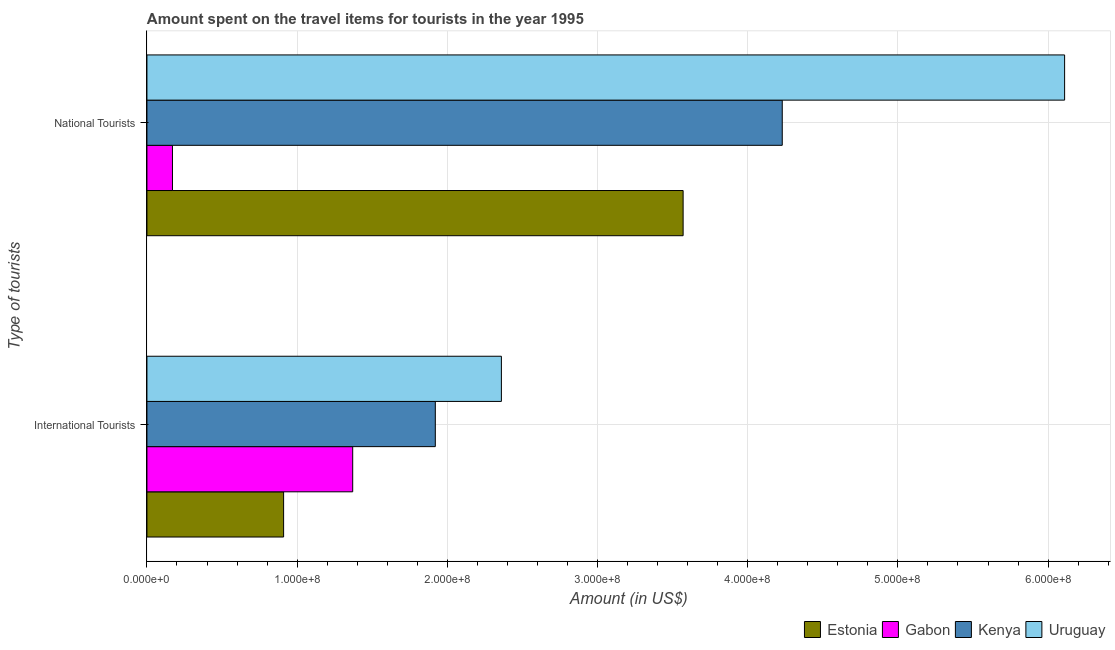How many groups of bars are there?
Your response must be concise. 2. Are the number of bars per tick equal to the number of legend labels?
Make the answer very short. Yes. How many bars are there on the 1st tick from the top?
Your response must be concise. 4. How many bars are there on the 2nd tick from the bottom?
Give a very brief answer. 4. What is the label of the 2nd group of bars from the top?
Offer a very short reply. International Tourists. What is the amount spent on travel items of national tourists in Uruguay?
Provide a succinct answer. 6.11e+08. Across all countries, what is the maximum amount spent on travel items of international tourists?
Your response must be concise. 2.36e+08. Across all countries, what is the minimum amount spent on travel items of national tourists?
Your answer should be very brief. 1.70e+07. In which country was the amount spent on travel items of international tourists maximum?
Offer a very short reply. Uruguay. In which country was the amount spent on travel items of national tourists minimum?
Give a very brief answer. Gabon. What is the total amount spent on travel items of international tourists in the graph?
Offer a terse response. 6.56e+08. What is the difference between the amount spent on travel items of national tourists in Gabon and that in Uruguay?
Offer a terse response. -5.94e+08. What is the difference between the amount spent on travel items of international tourists in Gabon and the amount spent on travel items of national tourists in Kenya?
Give a very brief answer. -2.86e+08. What is the average amount spent on travel items of national tourists per country?
Ensure brevity in your answer.  3.52e+08. What is the difference between the amount spent on travel items of national tourists and amount spent on travel items of international tourists in Gabon?
Your answer should be very brief. -1.20e+08. In how many countries, is the amount spent on travel items of national tourists greater than 480000000 US$?
Your answer should be very brief. 1. What is the ratio of the amount spent on travel items of international tourists in Uruguay to that in Gabon?
Offer a very short reply. 1.72. In how many countries, is the amount spent on travel items of international tourists greater than the average amount spent on travel items of international tourists taken over all countries?
Offer a very short reply. 2. What does the 3rd bar from the top in International Tourists represents?
Provide a short and direct response. Gabon. What does the 4th bar from the bottom in National Tourists represents?
Keep it short and to the point. Uruguay. Are all the bars in the graph horizontal?
Provide a short and direct response. Yes. How many countries are there in the graph?
Give a very brief answer. 4. What is the difference between two consecutive major ticks on the X-axis?
Ensure brevity in your answer.  1.00e+08. Are the values on the major ticks of X-axis written in scientific E-notation?
Your answer should be compact. Yes. Does the graph contain any zero values?
Offer a very short reply. No. Does the graph contain grids?
Make the answer very short. Yes. How are the legend labels stacked?
Make the answer very short. Horizontal. What is the title of the graph?
Your response must be concise. Amount spent on the travel items for tourists in the year 1995. Does "Rwanda" appear as one of the legend labels in the graph?
Your answer should be compact. No. What is the label or title of the Y-axis?
Offer a terse response. Type of tourists. What is the Amount (in US$) of Estonia in International Tourists?
Make the answer very short. 9.10e+07. What is the Amount (in US$) in Gabon in International Tourists?
Your answer should be compact. 1.37e+08. What is the Amount (in US$) in Kenya in International Tourists?
Offer a terse response. 1.92e+08. What is the Amount (in US$) in Uruguay in International Tourists?
Offer a very short reply. 2.36e+08. What is the Amount (in US$) of Estonia in National Tourists?
Your response must be concise. 3.57e+08. What is the Amount (in US$) of Gabon in National Tourists?
Make the answer very short. 1.70e+07. What is the Amount (in US$) in Kenya in National Tourists?
Give a very brief answer. 4.23e+08. What is the Amount (in US$) of Uruguay in National Tourists?
Your answer should be very brief. 6.11e+08. Across all Type of tourists, what is the maximum Amount (in US$) of Estonia?
Provide a succinct answer. 3.57e+08. Across all Type of tourists, what is the maximum Amount (in US$) of Gabon?
Your answer should be very brief. 1.37e+08. Across all Type of tourists, what is the maximum Amount (in US$) of Kenya?
Keep it short and to the point. 4.23e+08. Across all Type of tourists, what is the maximum Amount (in US$) in Uruguay?
Your response must be concise. 6.11e+08. Across all Type of tourists, what is the minimum Amount (in US$) in Estonia?
Provide a succinct answer. 9.10e+07. Across all Type of tourists, what is the minimum Amount (in US$) in Gabon?
Offer a terse response. 1.70e+07. Across all Type of tourists, what is the minimum Amount (in US$) in Kenya?
Your answer should be compact. 1.92e+08. Across all Type of tourists, what is the minimum Amount (in US$) in Uruguay?
Your answer should be compact. 2.36e+08. What is the total Amount (in US$) of Estonia in the graph?
Give a very brief answer. 4.48e+08. What is the total Amount (in US$) of Gabon in the graph?
Keep it short and to the point. 1.54e+08. What is the total Amount (in US$) in Kenya in the graph?
Your response must be concise. 6.15e+08. What is the total Amount (in US$) in Uruguay in the graph?
Your answer should be compact. 8.47e+08. What is the difference between the Amount (in US$) in Estonia in International Tourists and that in National Tourists?
Offer a terse response. -2.66e+08. What is the difference between the Amount (in US$) in Gabon in International Tourists and that in National Tourists?
Make the answer very short. 1.20e+08. What is the difference between the Amount (in US$) in Kenya in International Tourists and that in National Tourists?
Provide a succinct answer. -2.31e+08. What is the difference between the Amount (in US$) in Uruguay in International Tourists and that in National Tourists?
Offer a terse response. -3.75e+08. What is the difference between the Amount (in US$) in Estonia in International Tourists and the Amount (in US$) in Gabon in National Tourists?
Ensure brevity in your answer.  7.40e+07. What is the difference between the Amount (in US$) of Estonia in International Tourists and the Amount (in US$) of Kenya in National Tourists?
Give a very brief answer. -3.32e+08. What is the difference between the Amount (in US$) in Estonia in International Tourists and the Amount (in US$) in Uruguay in National Tourists?
Give a very brief answer. -5.20e+08. What is the difference between the Amount (in US$) in Gabon in International Tourists and the Amount (in US$) in Kenya in National Tourists?
Ensure brevity in your answer.  -2.86e+08. What is the difference between the Amount (in US$) of Gabon in International Tourists and the Amount (in US$) of Uruguay in National Tourists?
Give a very brief answer. -4.74e+08. What is the difference between the Amount (in US$) of Kenya in International Tourists and the Amount (in US$) of Uruguay in National Tourists?
Keep it short and to the point. -4.19e+08. What is the average Amount (in US$) of Estonia per Type of tourists?
Provide a short and direct response. 2.24e+08. What is the average Amount (in US$) in Gabon per Type of tourists?
Your answer should be compact. 7.70e+07. What is the average Amount (in US$) in Kenya per Type of tourists?
Your response must be concise. 3.08e+08. What is the average Amount (in US$) of Uruguay per Type of tourists?
Your answer should be very brief. 4.24e+08. What is the difference between the Amount (in US$) in Estonia and Amount (in US$) in Gabon in International Tourists?
Offer a very short reply. -4.60e+07. What is the difference between the Amount (in US$) of Estonia and Amount (in US$) of Kenya in International Tourists?
Make the answer very short. -1.01e+08. What is the difference between the Amount (in US$) of Estonia and Amount (in US$) of Uruguay in International Tourists?
Make the answer very short. -1.45e+08. What is the difference between the Amount (in US$) of Gabon and Amount (in US$) of Kenya in International Tourists?
Your response must be concise. -5.50e+07. What is the difference between the Amount (in US$) in Gabon and Amount (in US$) in Uruguay in International Tourists?
Ensure brevity in your answer.  -9.90e+07. What is the difference between the Amount (in US$) of Kenya and Amount (in US$) of Uruguay in International Tourists?
Your answer should be very brief. -4.40e+07. What is the difference between the Amount (in US$) in Estonia and Amount (in US$) in Gabon in National Tourists?
Provide a short and direct response. 3.40e+08. What is the difference between the Amount (in US$) in Estonia and Amount (in US$) in Kenya in National Tourists?
Offer a very short reply. -6.60e+07. What is the difference between the Amount (in US$) of Estonia and Amount (in US$) of Uruguay in National Tourists?
Make the answer very short. -2.54e+08. What is the difference between the Amount (in US$) in Gabon and Amount (in US$) in Kenya in National Tourists?
Your answer should be very brief. -4.06e+08. What is the difference between the Amount (in US$) of Gabon and Amount (in US$) of Uruguay in National Tourists?
Ensure brevity in your answer.  -5.94e+08. What is the difference between the Amount (in US$) of Kenya and Amount (in US$) of Uruguay in National Tourists?
Your answer should be very brief. -1.88e+08. What is the ratio of the Amount (in US$) in Estonia in International Tourists to that in National Tourists?
Make the answer very short. 0.25. What is the ratio of the Amount (in US$) in Gabon in International Tourists to that in National Tourists?
Make the answer very short. 8.06. What is the ratio of the Amount (in US$) in Kenya in International Tourists to that in National Tourists?
Give a very brief answer. 0.45. What is the ratio of the Amount (in US$) of Uruguay in International Tourists to that in National Tourists?
Make the answer very short. 0.39. What is the difference between the highest and the second highest Amount (in US$) of Estonia?
Ensure brevity in your answer.  2.66e+08. What is the difference between the highest and the second highest Amount (in US$) of Gabon?
Make the answer very short. 1.20e+08. What is the difference between the highest and the second highest Amount (in US$) of Kenya?
Your response must be concise. 2.31e+08. What is the difference between the highest and the second highest Amount (in US$) of Uruguay?
Give a very brief answer. 3.75e+08. What is the difference between the highest and the lowest Amount (in US$) of Estonia?
Your answer should be compact. 2.66e+08. What is the difference between the highest and the lowest Amount (in US$) in Gabon?
Ensure brevity in your answer.  1.20e+08. What is the difference between the highest and the lowest Amount (in US$) in Kenya?
Your response must be concise. 2.31e+08. What is the difference between the highest and the lowest Amount (in US$) in Uruguay?
Provide a succinct answer. 3.75e+08. 